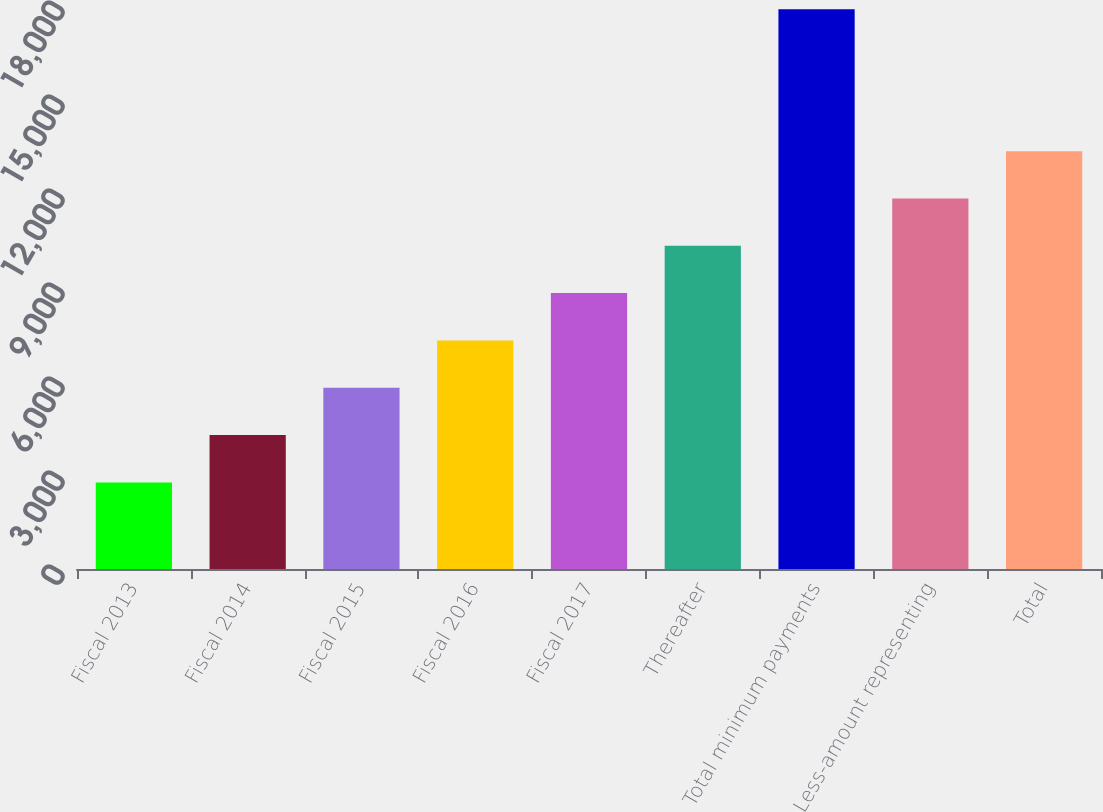Convert chart to OTSL. <chart><loc_0><loc_0><loc_500><loc_500><bar_chart><fcel>Fiscal 2013<fcel>Fiscal 2014<fcel>Fiscal 2015<fcel>Fiscal 2016<fcel>Fiscal 2017<fcel>Thereafter<fcel>Total minimum payments<fcel>Less-amount representing<fcel>Total<nl><fcel>2764<fcel>4274.3<fcel>5784.6<fcel>7294.9<fcel>8805.2<fcel>10315.5<fcel>17867<fcel>11825.8<fcel>13336.1<nl></chart> 